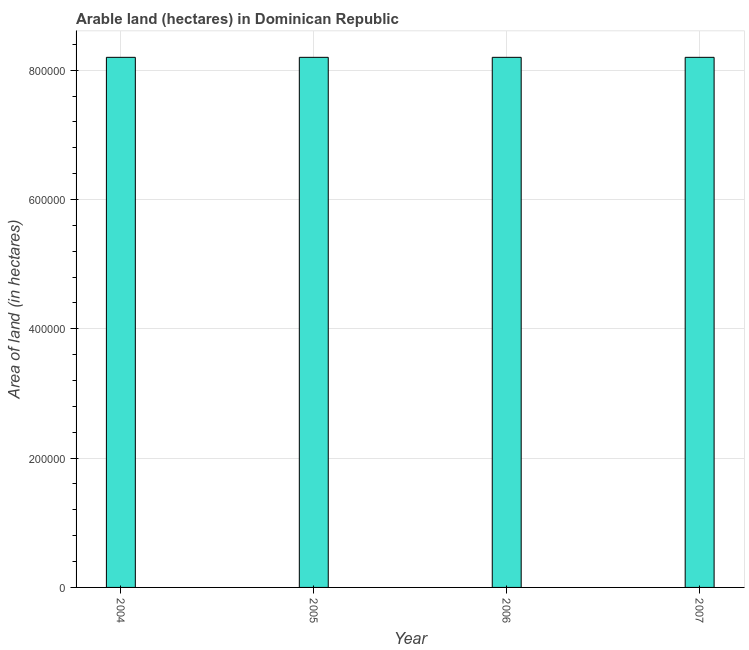Does the graph contain any zero values?
Make the answer very short. No. What is the title of the graph?
Ensure brevity in your answer.  Arable land (hectares) in Dominican Republic. What is the label or title of the Y-axis?
Keep it short and to the point. Area of land (in hectares). What is the area of land in 2004?
Provide a succinct answer. 8.20e+05. Across all years, what is the maximum area of land?
Make the answer very short. 8.20e+05. Across all years, what is the minimum area of land?
Your answer should be compact. 8.20e+05. In which year was the area of land maximum?
Provide a short and direct response. 2004. In which year was the area of land minimum?
Your response must be concise. 2004. What is the sum of the area of land?
Make the answer very short. 3.28e+06. What is the difference between the area of land in 2006 and 2007?
Offer a terse response. 0. What is the average area of land per year?
Ensure brevity in your answer.  8.20e+05. What is the median area of land?
Offer a very short reply. 8.20e+05. Is the area of land in 2004 less than that in 2005?
Your answer should be compact. No. Is the difference between the area of land in 2004 and 2006 greater than the difference between any two years?
Offer a terse response. Yes. What is the difference between the highest and the second highest area of land?
Give a very brief answer. 0. In how many years, is the area of land greater than the average area of land taken over all years?
Offer a very short reply. 0. How many years are there in the graph?
Provide a short and direct response. 4. What is the Area of land (in hectares) in 2004?
Offer a very short reply. 8.20e+05. What is the Area of land (in hectares) of 2005?
Provide a succinct answer. 8.20e+05. What is the Area of land (in hectares) of 2006?
Your answer should be compact. 8.20e+05. What is the Area of land (in hectares) in 2007?
Provide a short and direct response. 8.20e+05. What is the difference between the Area of land (in hectares) in 2005 and 2006?
Offer a very short reply. 0. What is the difference between the Area of land (in hectares) in 2005 and 2007?
Provide a short and direct response. 0. What is the difference between the Area of land (in hectares) in 2006 and 2007?
Keep it short and to the point. 0. What is the ratio of the Area of land (in hectares) in 2004 to that in 2005?
Keep it short and to the point. 1. 